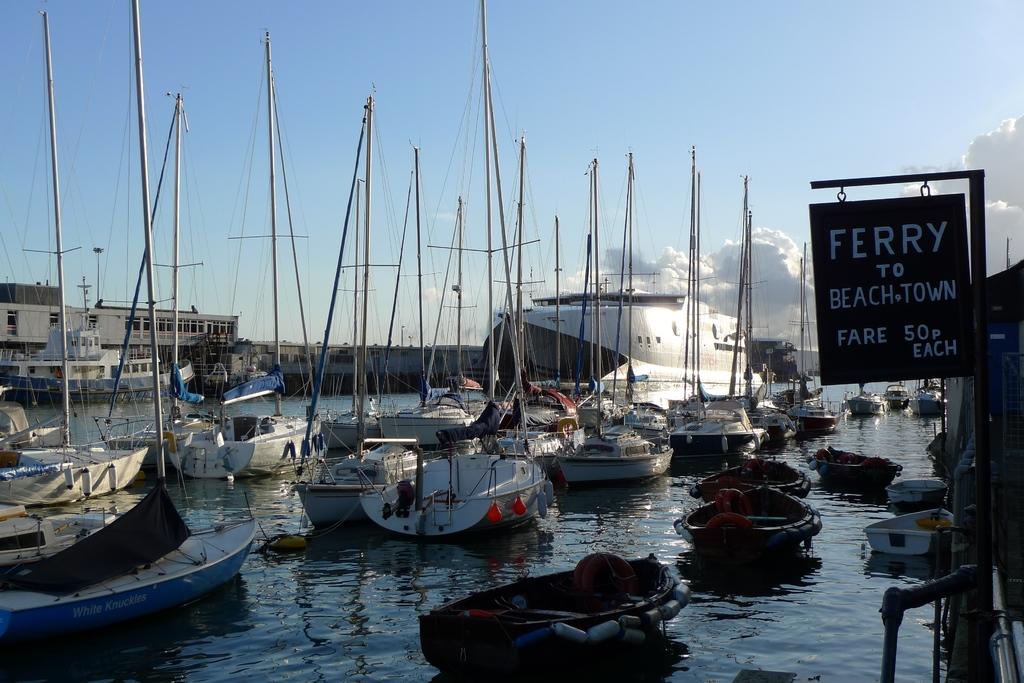Does this place look like a dock to you?
Make the answer very short. Answering does not require reading text in the image. How much is the fare?
Your response must be concise. 50p. 